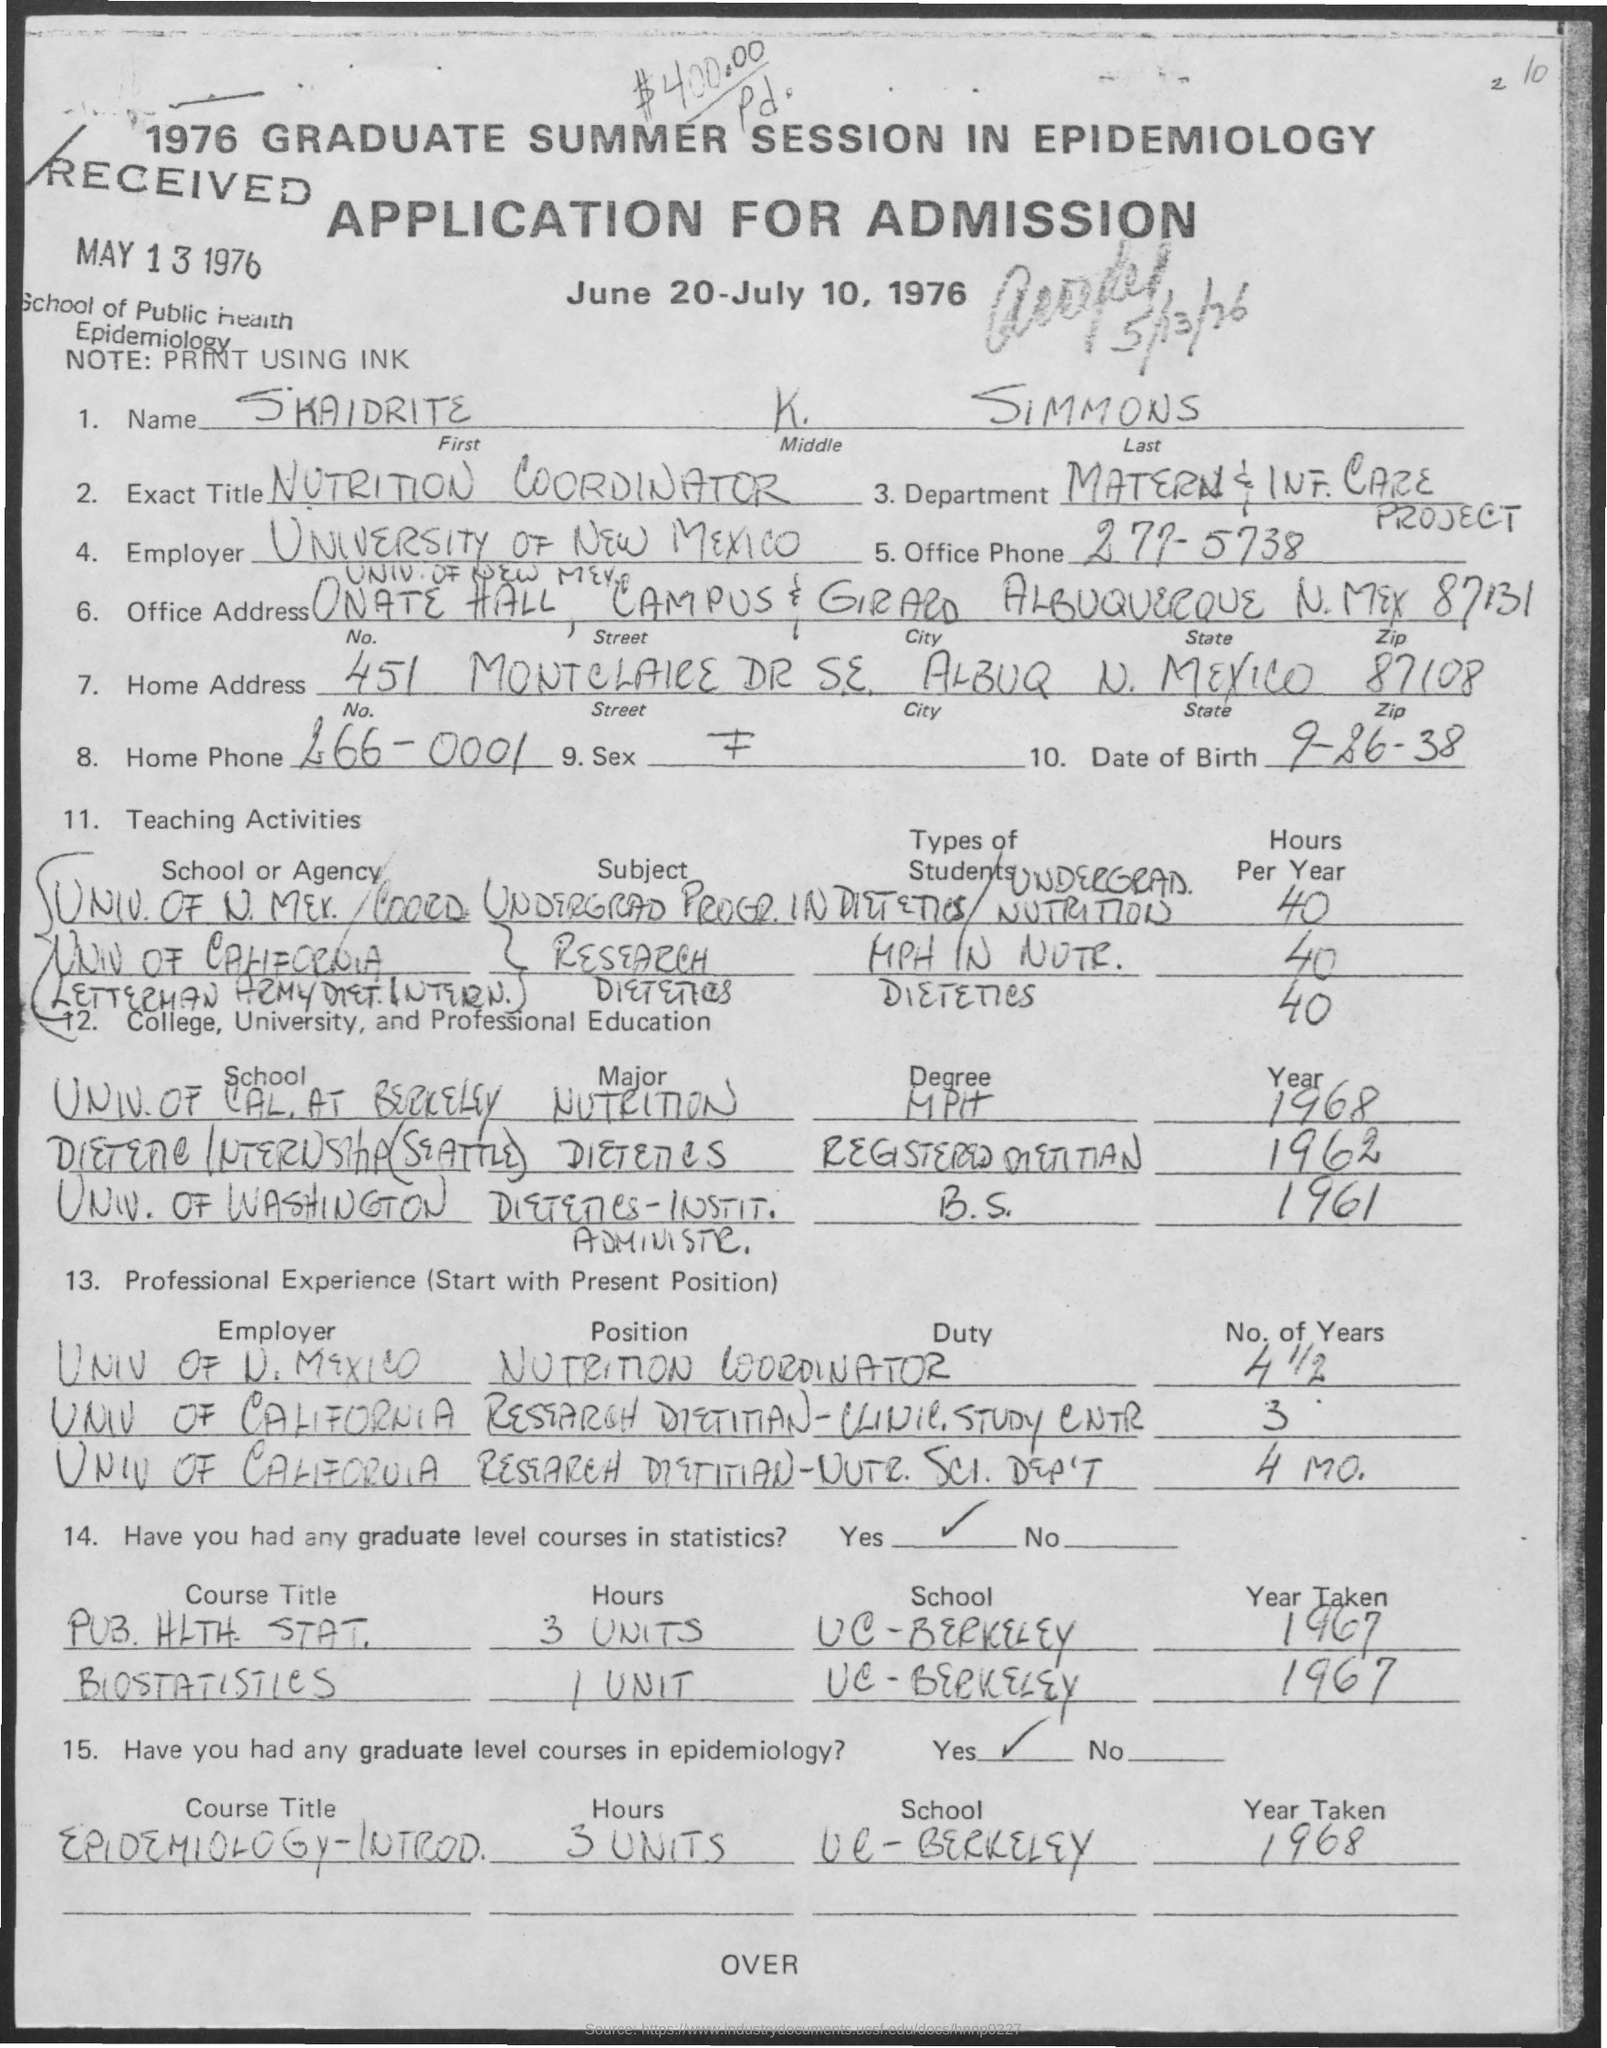Mention a couple of crucial points in this snapshot. The applicant belongs to the Department of Maternal and Infant Care. The full name of the applicant is SKAIDRITE K. SIMMONS. The date of birth of the applicant is September 26, 1938. The applicant's exact title is 'NUTRITION COORDINATOR.' The application form was received on May 13, 1976. 